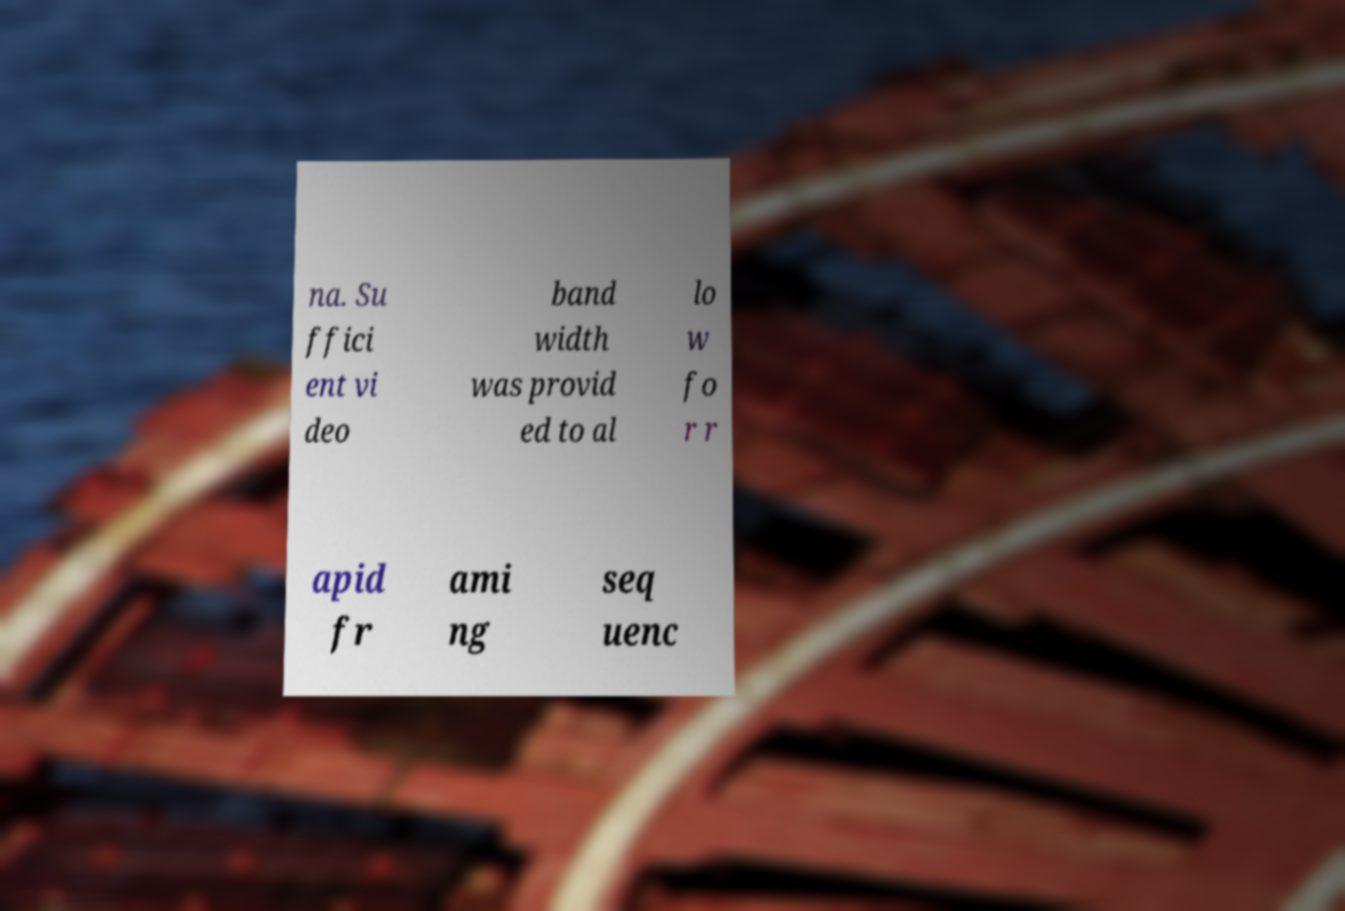I need the written content from this picture converted into text. Can you do that? na. Su ffici ent vi deo band width was provid ed to al lo w fo r r apid fr ami ng seq uenc 